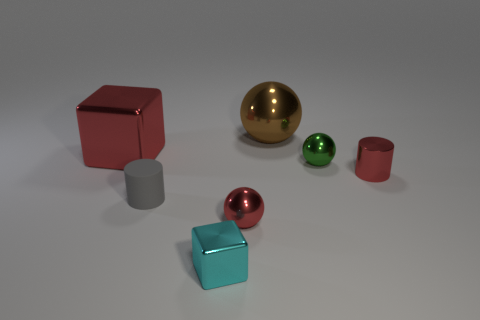Are there any other things that are the same material as the gray cylinder?
Your answer should be compact. No. How many cubes are large red metal things or gray rubber things?
Offer a very short reply. 1. Does the large thing that is on the right side of the red metal sphere have the same material as the small green sphere?
Your answer should be very brief. Yes. How many other objects are the same size as the gray thing?
Provide a succinct answer. 4. What number of large objects are yellow matte cylinders or metallic objects?
Give a very brief answer. 2. Do the big block and the shiny cylinder have the same color?
Offer a terse response. Yes. Is the number of large objects that are right of the cyan shiny thing greater than the number of red metal blocks that are on the right side of the green shiny thing?
Make the answer very short. Yes. Do the small sphere in front of the tiny gray cylinder and the large block have the same color?
Your answer should be very brief. Yes. Is there anything else of the same color as the tiny metallic cube?
Ensure brevity in your answer.  No. Is the number of tiny balls that are on the left side of the brown shiny object greater than the number of tiny yellow cubes?
Keep it short and to the point. Yes. 